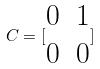<formula> <loc_0><loc_0><loc_500><loc_500>C = [ \begin{matrix} 0 & 1 \\ 0 & 0 \end{matrix} ]</formula> 